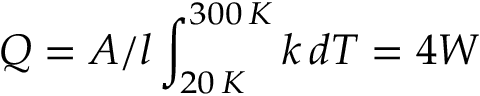Convert formula to latex. <formula><loc_0><loc_0><loc_500><loc_500>Q = A / l \int _ { 2 0 \, K } ^ { 3 0 0 \, K } k \, d T = 4 W</formula> 